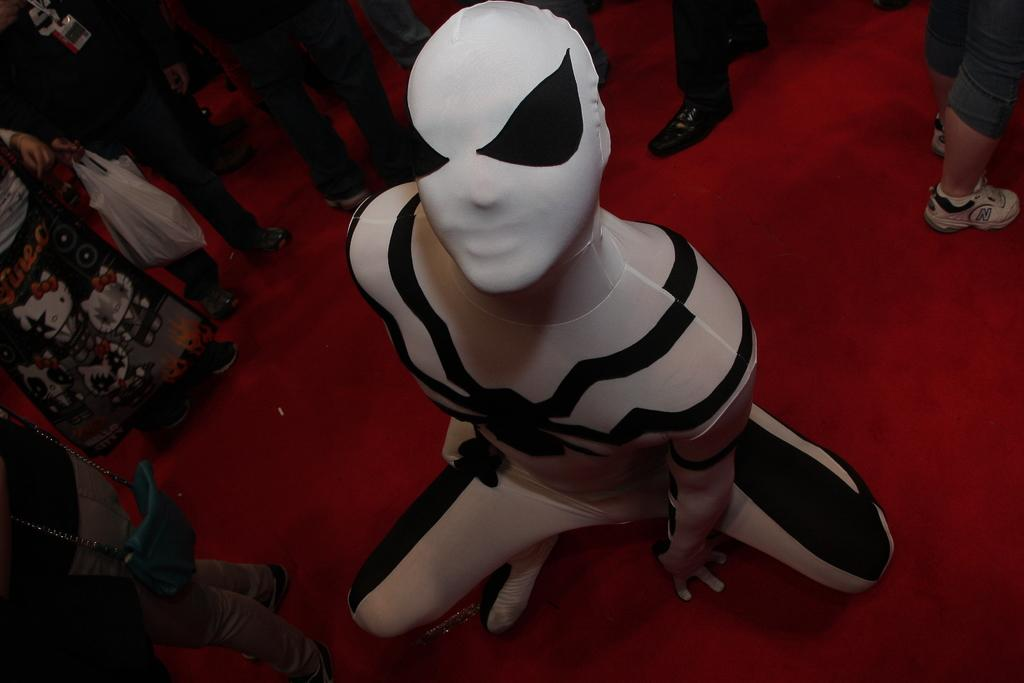What is the main setting of the image? The main setting of the image is a red carpet. What can be observed about the people in the image? There are many people on the red carpet. Can you describe the position of a specific person in the image? A person is in a crouch position in the foreground. What is the person in the crouch position wearing? The person in the crouch position is wearing a suit. What type of owl can be seen perched on the person's shoulder in the image? There is no owl present in the image; the person in the crouch position is wearing a suit. Can you tell me who the coach is in the image? There is no coach or any indication of a sports team in the image; it features people on a red carpet. 